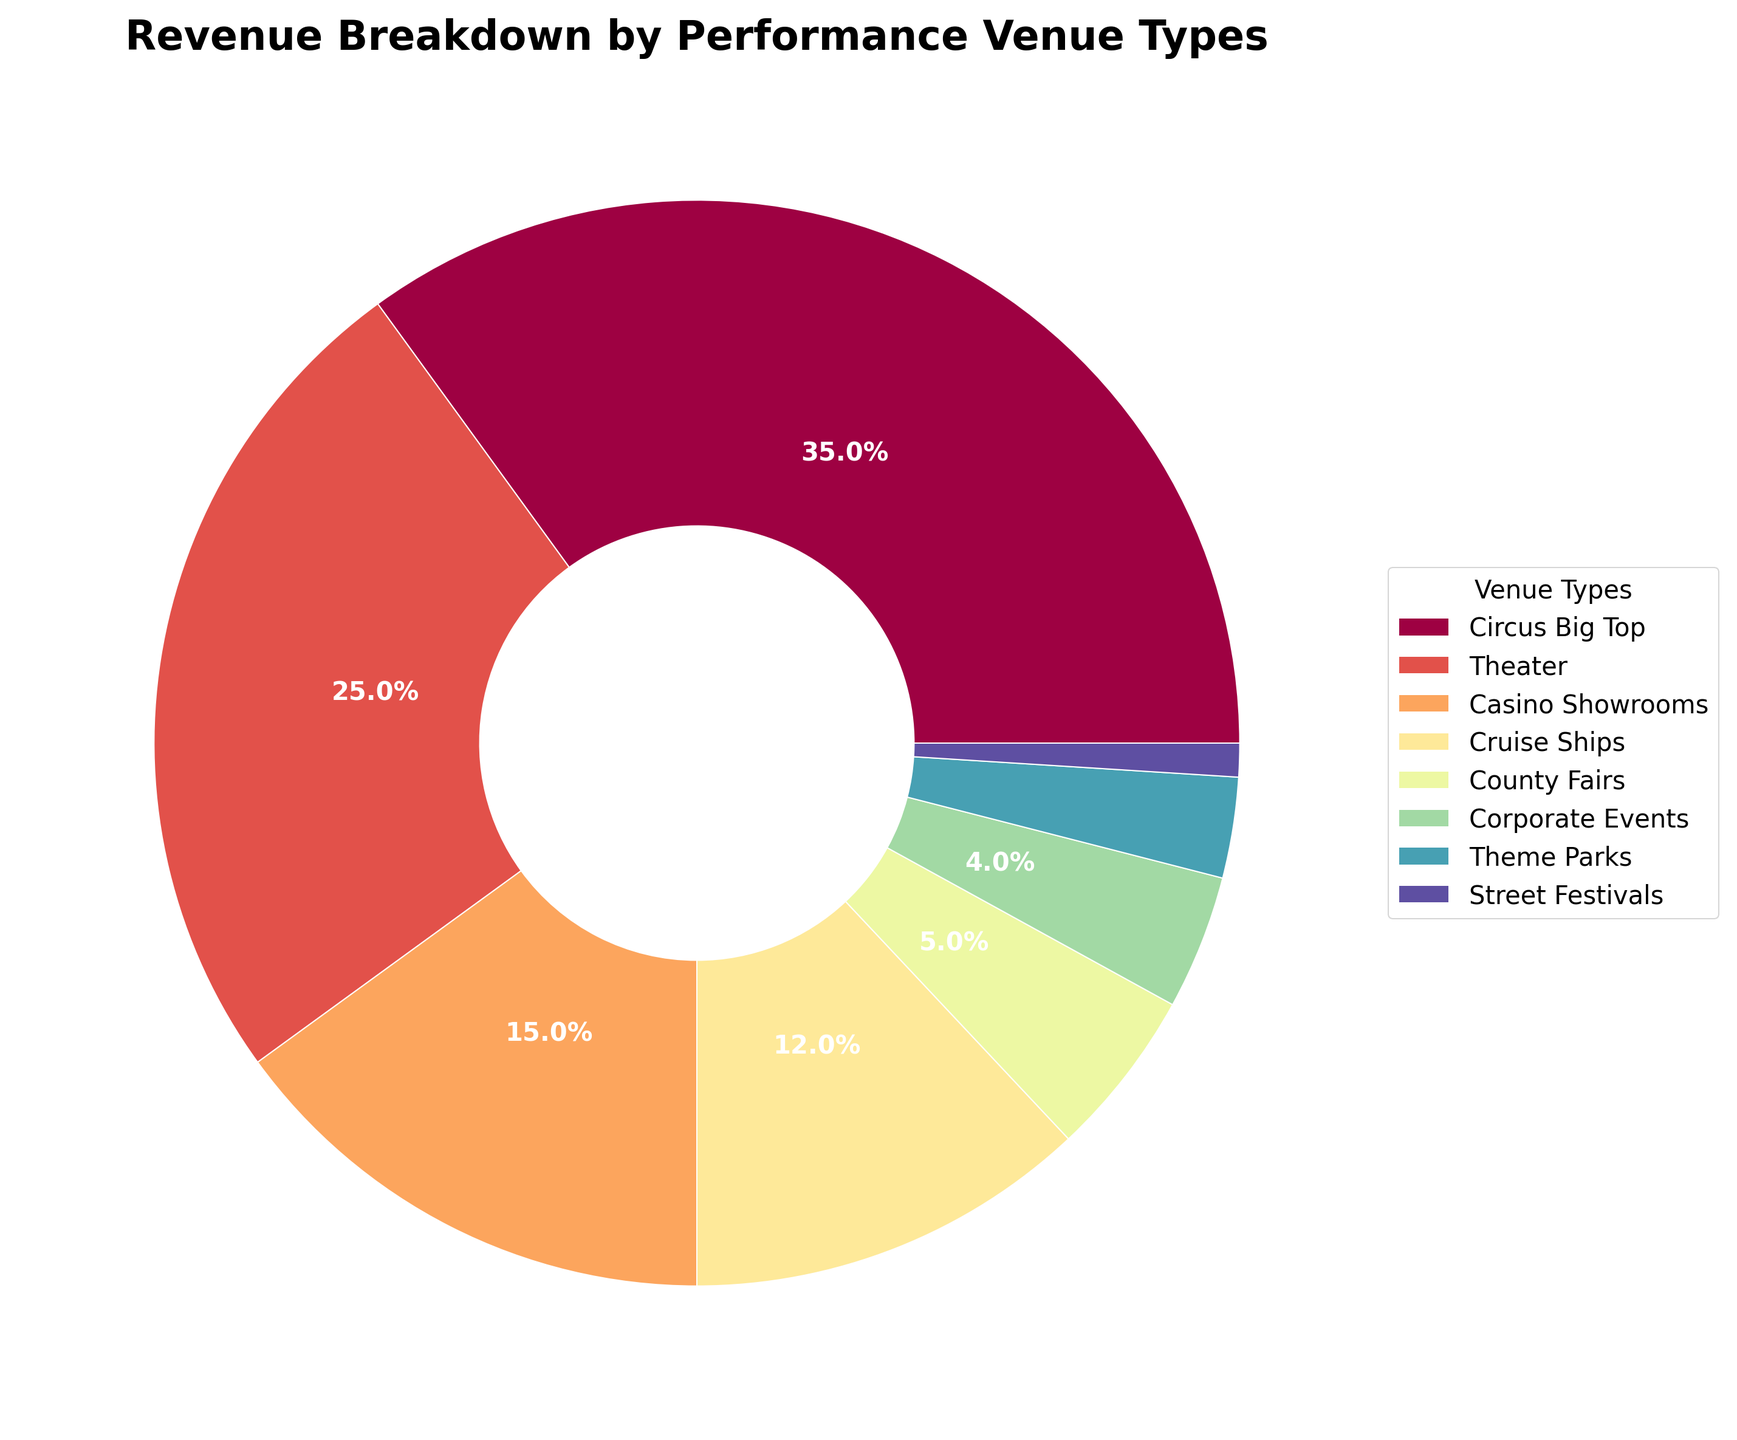What portion of the total revenue is generated by Circus Big Top and Theater combined? Circus Big Top contributes 35% and Theater contributes 25%. To find the combined portion, you add the two percentages together: 35% + 25% = 60%
Answer: 60% Which venue type generates the least revenue? By looking at the smallest segment in the pie chart, you can see that Street Festivals generate the least revenue at 1%
Answer: Street Festivals How much greater is the revenue from Circus Big Top compared to Cruise Ships? Circus Big Top generates 35% of the revenue, while Cruise Ships generate 12%. Subtract Cruise Ships' percentage from Circus Big Top's percentage: 35% - 12% = 23%
Answer: 23% What is the combined revenue percentage of Corporate Events and Theme Parks? Corporate Events generate 4% and Theme Parks generate 3%. Adding these together: 4% + 3% = 7%
Answer: 7% What can be inferred about the popularity of county fairs compared to street festivals? County Fairs generate 5% of the revenue, which is significantly higher than the 1% generated by Street Festivals. This suggests County Fairs are more popular or lucrative
Answer: County Fairs are more popular Which three venue types contribute the most to the revenue? The top three segments in the pie chart are the largest portions: Circus Big Top (35%), Theater (25%), and Casino Showrooms (15%)
Answer: Circus Big Top, Theater, Casino Showrooms If one considers venues contributing at least 10% of the revenue significant, how many venues fall into this category? Circus Big Top (35%), Theater (25%), Casino Showrooms (15%), and Cruise Ships (12%) all contribute at least 10% of the revenue. Counting these, there are four venues
Answer: 4 Which venue type’s revenue is almost the same as Casino Showrooms and County Fairs combined? Casino Showrooms generate 15% and County Fairs generate 5%. Their combined contribution is 20%. Theater, which generates 25%, is the closest to this value
Answer: Theater What is the visual representation of the revenue generated by Corporate Events in relation to Theme Parks? Both Corporate Events (4%) and Theme Parks (3%) have small segments in the pie chart, with Corporate Events being slightly larger, indicating higher revenue
Answer: Corporate Events are slightly larger than Theme Parks 